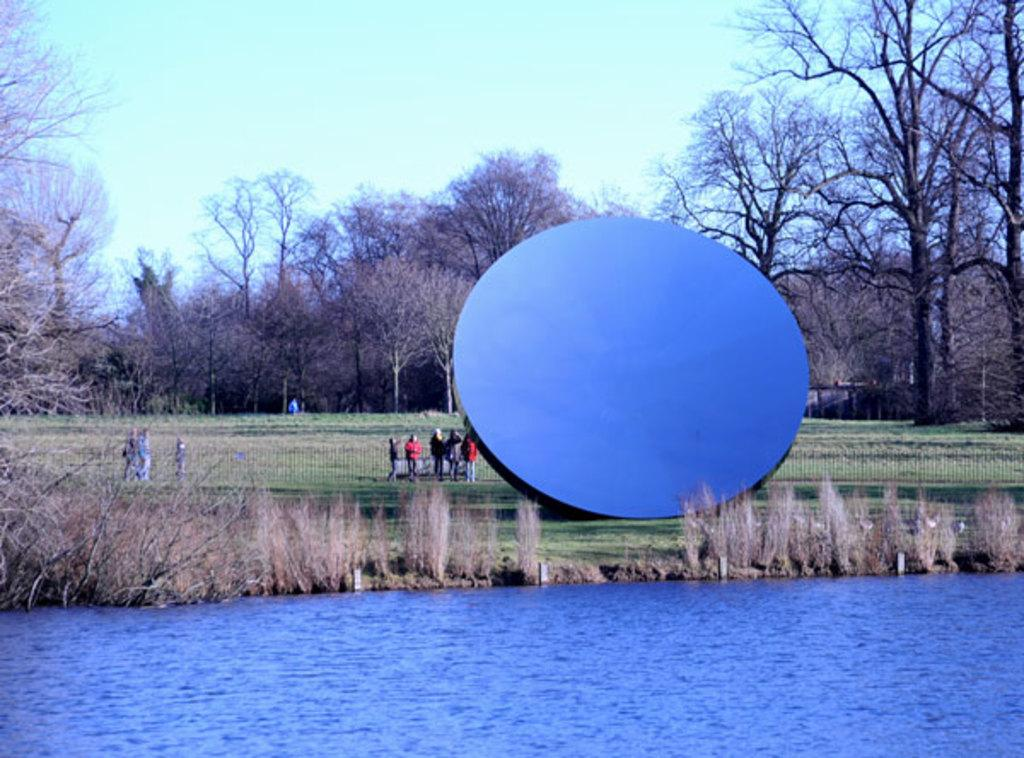What is the main subject in the image? There is a statue in the image. Are there any people in the image? Yes, there are persons standing beside the statue. What can be seen in the background of the image? The sky with clouds, trees, the ground, an iron grill, plants, and water are visible in the background. What type of potato is being used as a prop in the image? There is no potato present in the image. 